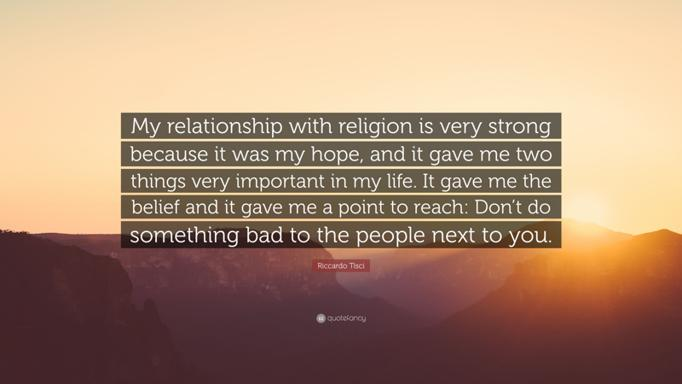What are the two important things the speaker's relationship with religion gave them? The speaker's close relationship with religion brought them not only belief but also a moral compass—a point to aim towards, which emphasizes the significance of not causing harm to others. This foundational belief system provided hope and guided them in meaningful interaction with the world. 